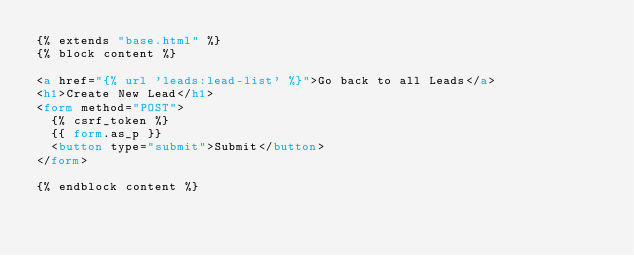<code> <loc_0><loc_0><loc_500><loc_500><_HTML_>{% extends "base.html" %}
{% block content %}

<a href="{% url 'leads:lead-list' %}">Go back to all Leads</a>
<h1>Create New Lead</h1>
<form method="POST">
  {% csrf_token %}
  {{ form.as_p }}
  <button type="submit">Submit</button>
</form>

{% endblock content %}</code> 